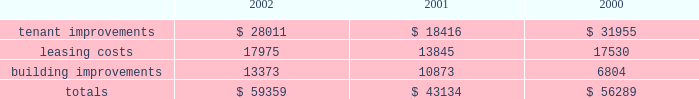D u k e r e a l t y c o r p o r a t i o n 1 6 2 0 0 2 a n n u a l r e p o r t management 2019s discussion and analysis of financial conditionand results of operations the indenture governing the company 2019s unsecured notes also requires the company to comply with financial ratios and other covenants regarding the operations of the company .
The company is currently in compliance with all such covenants and expects to remain in compliance in the foreseeable future .
In january 2003 , the company completed an issuance of unsecured debt totaling $ 175 million bearing interest at 5.25% ( 5.25 % ) , due 2010 .
Sale of real estate assets the company utilizes sales of real estate assets as an additional source of liquidity .
During 2000 and 2001 , the company engaged in a capital-recycling program that resulted in sales of over $ 1 billion of real estate assets during these two years .
In 2002 , this program was substantially reduced as capital needs were met through other sources and the slower business climate provided few opportunities to profitably reinvest sales proceeds .
The company continues to pursue opportunities to sell real estate assets when beneficial to the long-term strategy of the company .
Uses of liquidity the company 2019s principal uses of liquidity include the following : 2022 property investments and recurring leasing/capital costs ; 2022 dividends and distributions to shareholders and unitholders ; 2022 long-term debt maturities ; and 2022 the company 2019s common stock repurchase program .
Property investments and other capital expenditures one of the company 2019s principal uses of its liquidity is for the development , acquisition and recurring leasing/capital expendi- tures of its real estate investments .
A summary of the company 2019s recurring capital expenditures is as follows ( in thousands ) : dividends and distributions in order to qualify as a reit for federal income tax purposes , the company must currently distribute at least 90% ( 90 % ) of its taxable income to its shareholders and duke realty limited partnership ( 201cdrlp 201d ) unitholders .
The company paid dividends of $ 1.81 , $ 1.76 and $ 1.64 for the years ended december 31 , 2002 , 2001 and 2000 , respectively .
The company expects to continue to distribute taxable earnings to meet the requirements to maintain its reit status .
However , distributions are declared at the discretion of the company 2019s board of directors and are subject to actual cash available for distribution , the company 2019s financial condition , capital requirements and such other factors as the company 2019s board of directors deems relevant .
Debt maturities debt outstanding at december 31 , 2002 , totaled $ 2.1 billion with a weighted average interest rate of 6.25% ( 6.25 % ) maturing at various dates through 2028 .
The company had $ 1.8 billion of unsecured debt and $ 299.1 million of secured debt outstanding at december 31 , 2002 .
Scheduled principal amortization of such debt totaled $ 10.9 million for the year ended december 31 , 2002 .
Following is a summary of the scheduled future amortization and maturities of the company 2019s indebtedness at december 31 , 2002 ( in thousands ) : .

In 2002 what was the percent of the company total future amortization and maturities of indebtedness associated with leasing costs? 
Computations: (17975 / 59359)
Answer: 0.30282. 